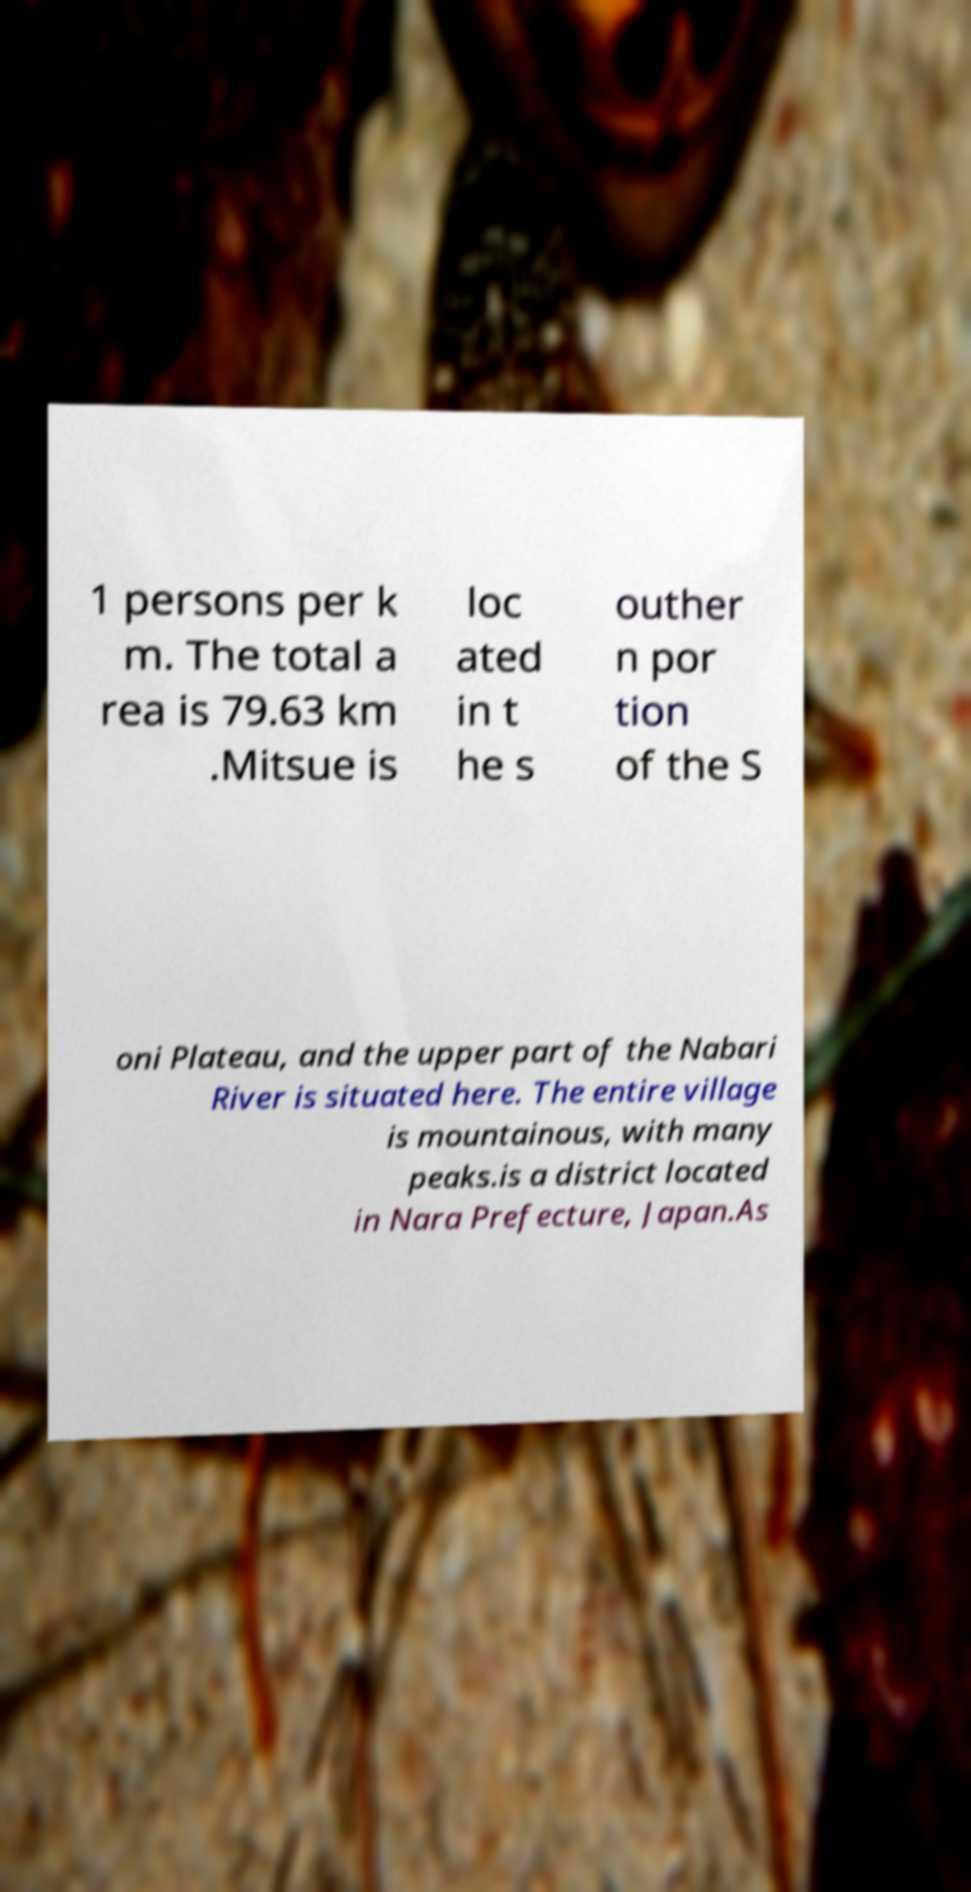What messages or text are displayed in this image? I need them in a readable, typed format. 1 persons per k m. The total a rea is 79.63 km .Mitsue is loc ated in t he s outher n por tion of the S oni Plateau, and the upper part of the Nabari River is situated here. The entire village is mountainous, with many peaks.is a district located in Nara Prefecture, Japan.As 